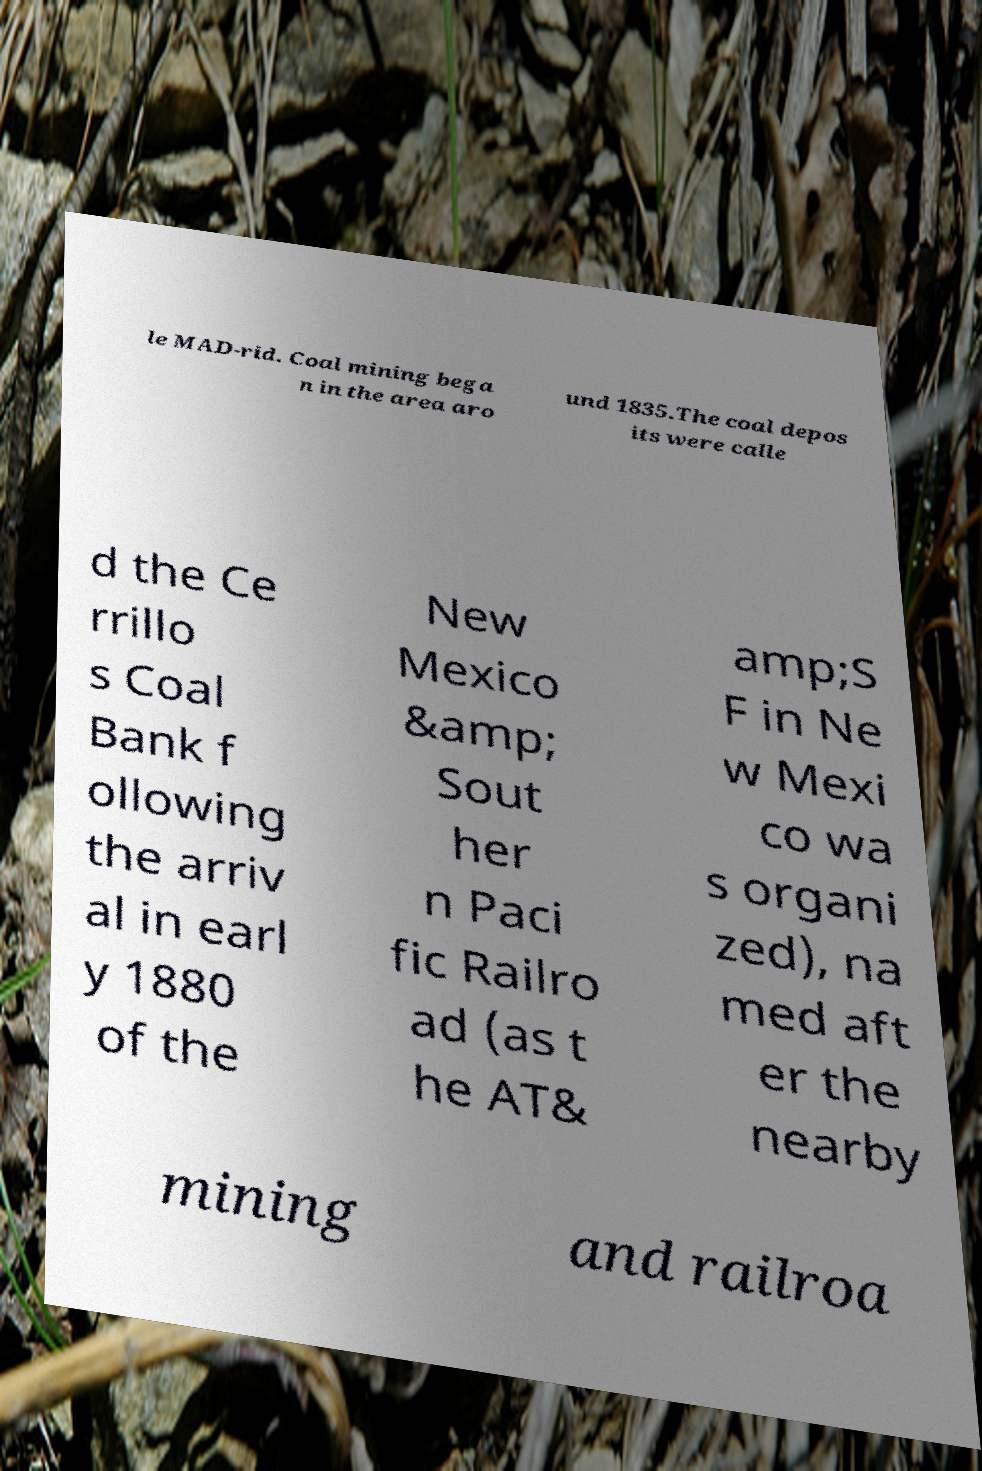Could you assist in decoding the text presented in this image and type it out clearly? le MAD-rid. Coal mining bega n in the area aro und 1835.The coal depos its were calle d the Ce rrillo s Coal Bank f ollowing the arriv al in earl y 1880 of the New Mexico &amp; Sout her n Paci fic Railro ad (as t he AT& amp;S F in Ne w Mexi co wa s organi zed), na med aft er the nearby mining and railroa 